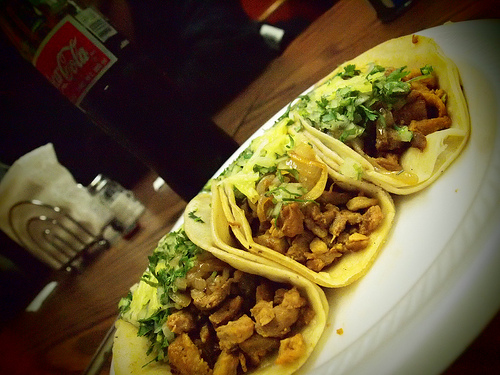<image>
Is the taco to the left of the taco? No. The taco is not to the left of the taco. From this viewpoint, they have a different horizontal relationship. 